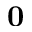Convert formula to latex. <formula><loc_0><loc_0><loc_500><loc_500>0</formula> 